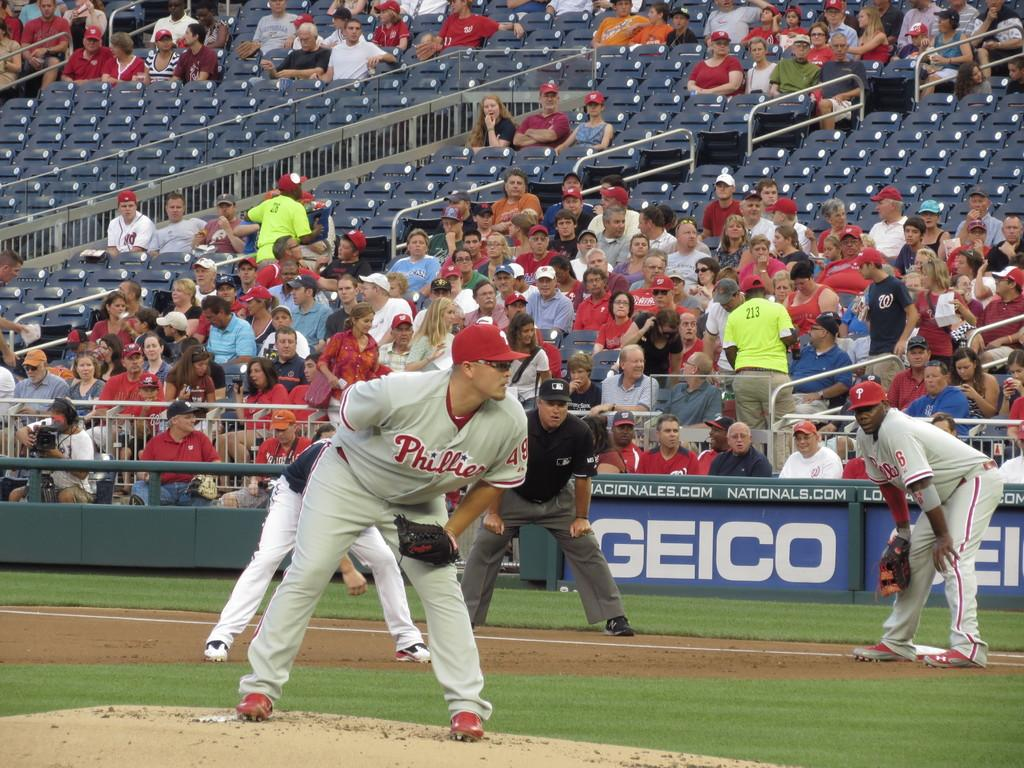<image>
Describe the image concisely. phillies pitcher getting ready to throw ball and geico banners on wall in front of stands 